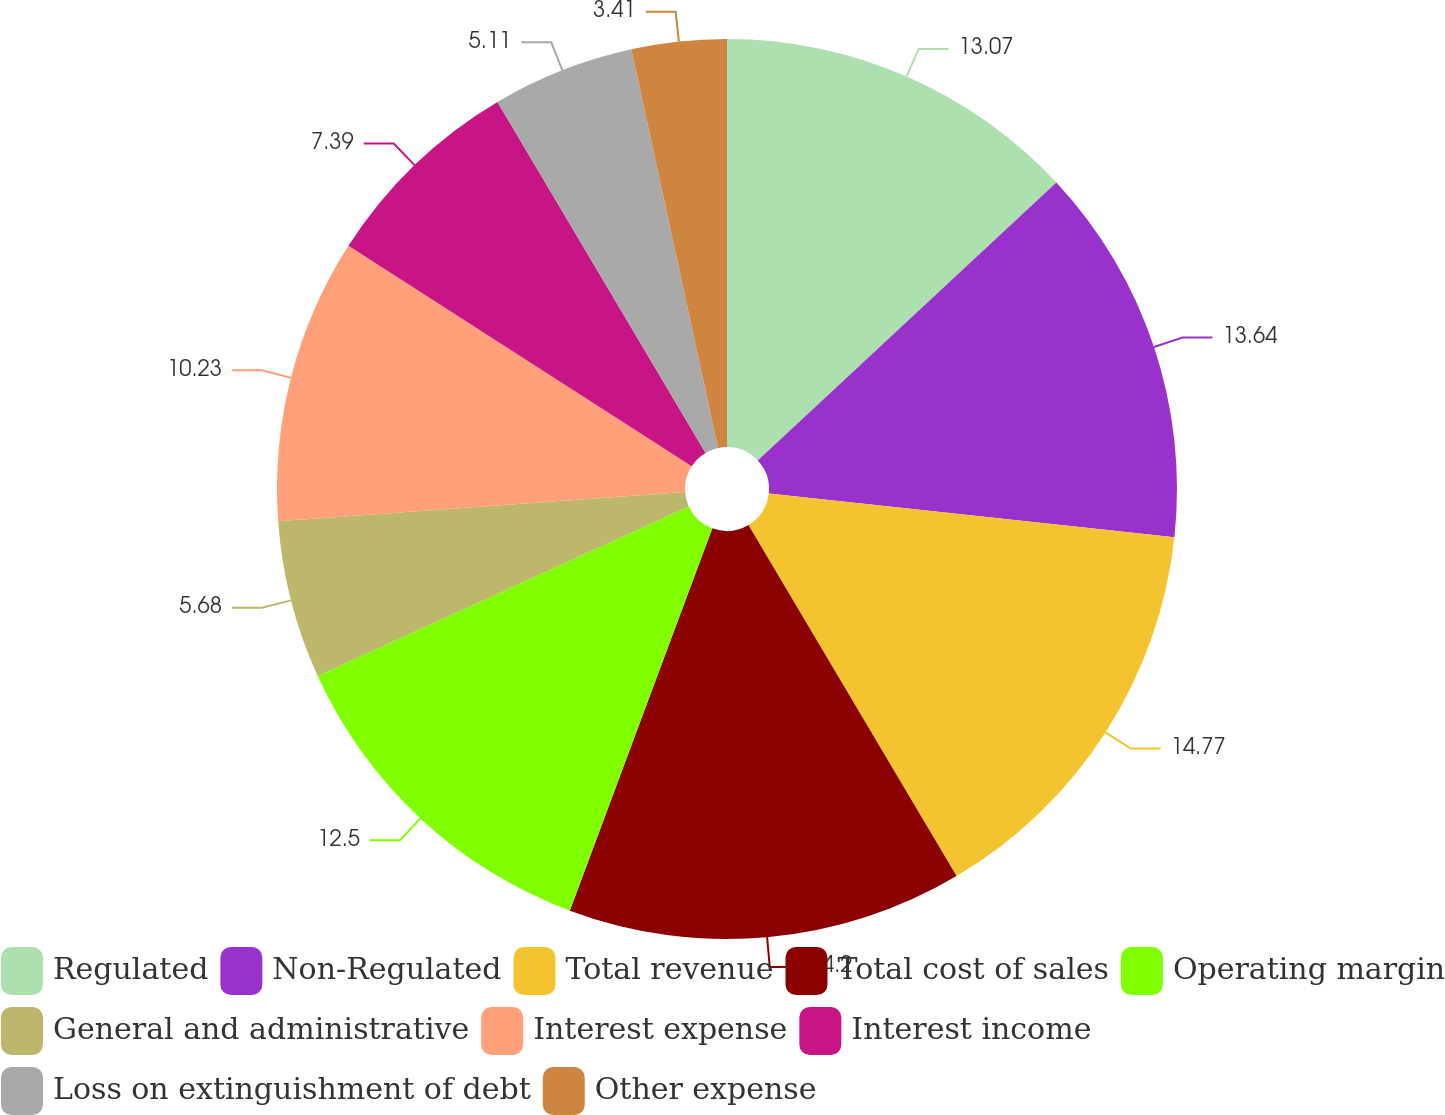Convert chart. <chart><loc_0><loc_0><loc_500><loc_500><pie_chart><fcel>Regulated<fcel>Non-Regulated<fcel>Total revenue<fcel>Total cost of sales<fcel>Operating margin<fcel>General and administrative<fcel>Interest expense<fcel>Interest income<fcel>Loss on extinguishment of debt<fcel>Other expense<nl><fcel>13.07%<fcel>13.64%<fcel>14.77%<fcel>14.2%<fcel>12.5%<fcel>5.68%<fcel>10.23%<fcel>7.39%<fcel>5.11%<fcel>3.41%<nl></chart> 